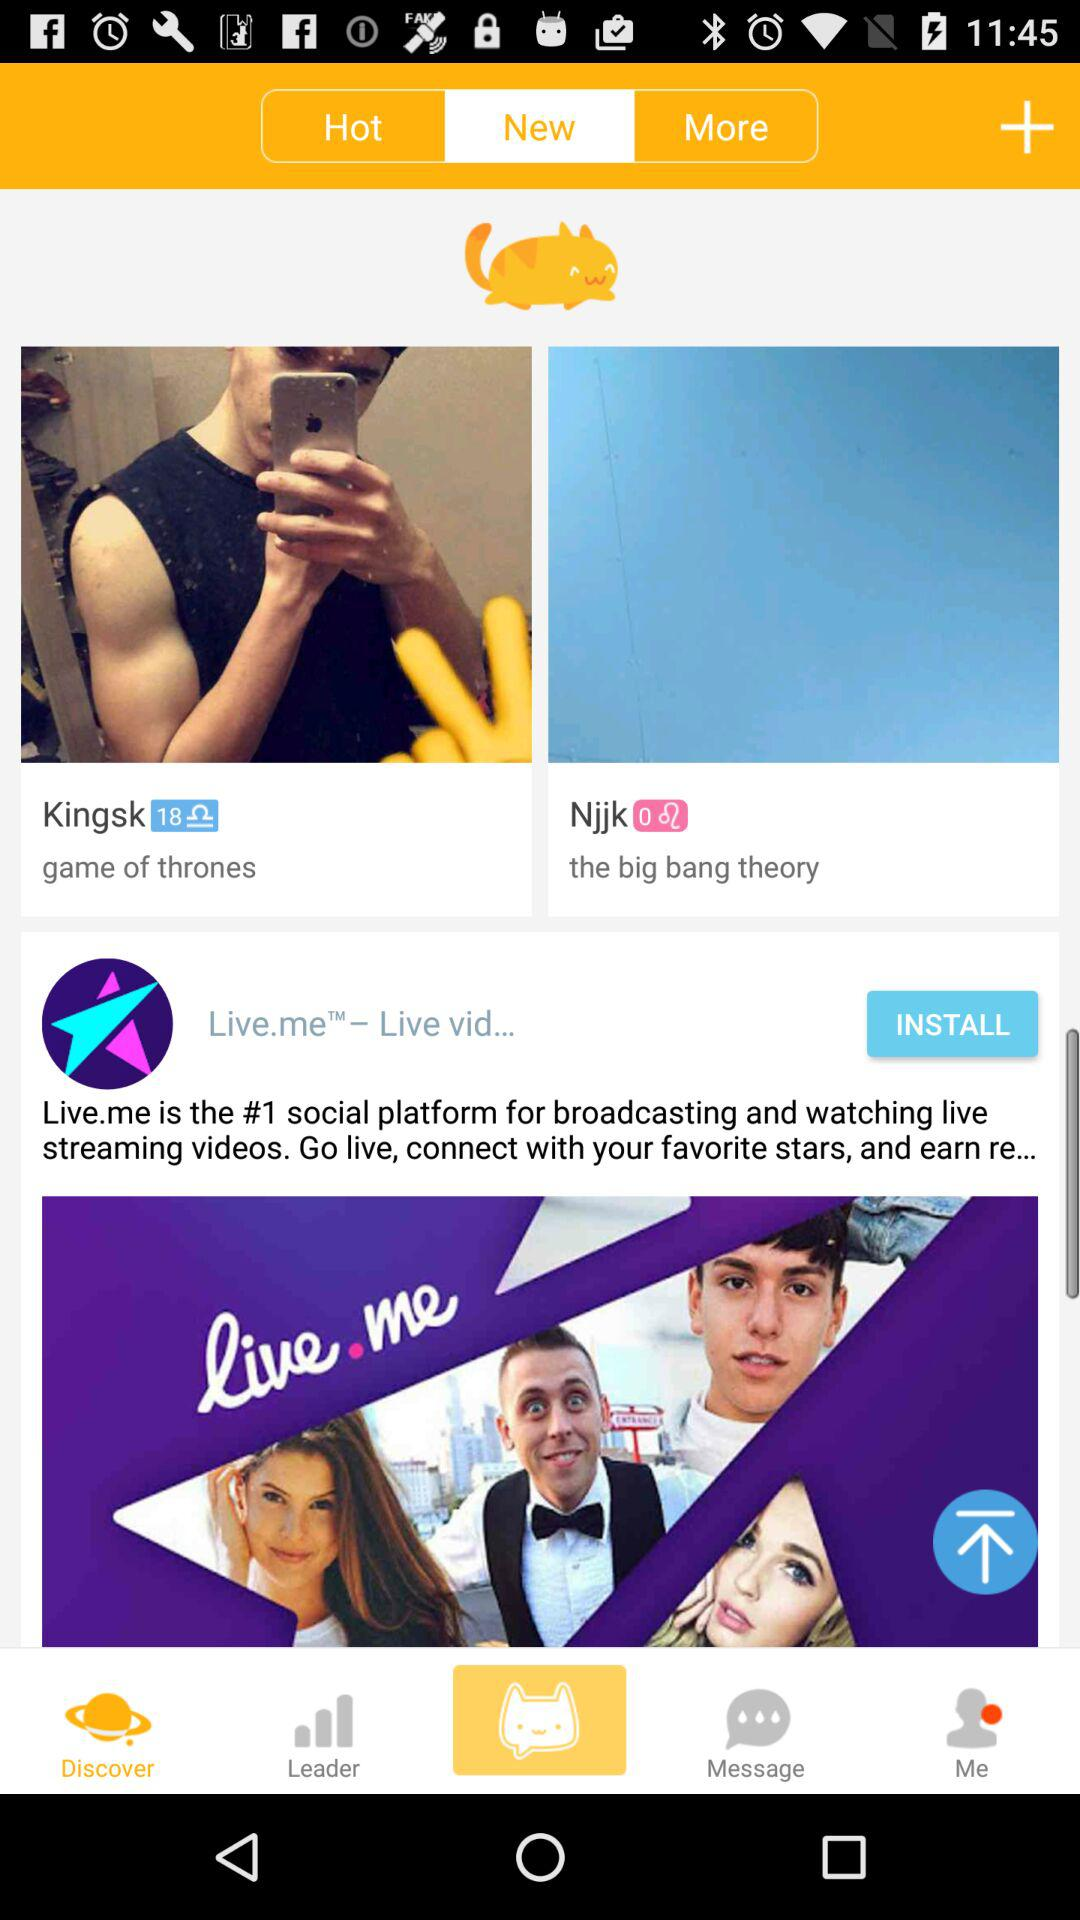Which step am I on? You are on the sixth step. 